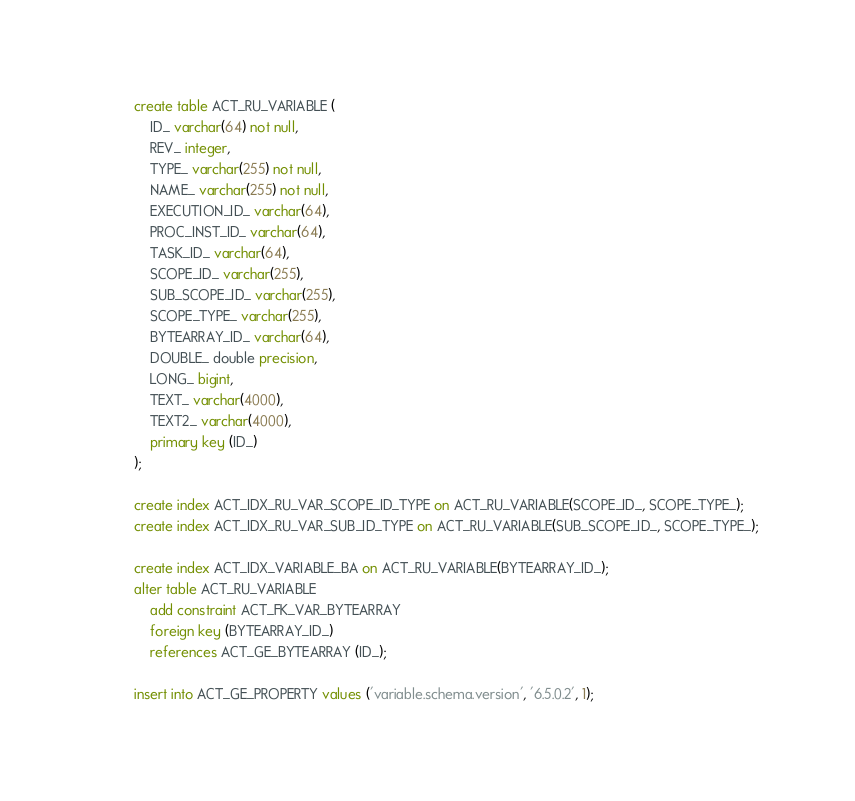Convert code to text. <code><loc_0><loc_0><loc_500><loc_500><_SQL_>create table ACT_RU_VARIABLE (
    ID_ varchar(64) not null,
    REV_ integer,
    TYPE_ varchar(255) not null,
    NAME_ varchar(255) not null,
    EXECUTION_ID_ varchar(64),
    PROC_INST_ID_ varchar(64),
    TASK_ID_ varchar(64),
    SCOPE_ID_ varchar(255),
    SUB_SCOPE_ID_ varchar(255),
    SCOPE_TYPE_ varchar(255),
    BYTEARRAY_ID_ varchar(64),
    DOUBLE_ double precision,
    LONG_ bigint,
    TEXT_ varchar(4000),
    TEXT2_ varchar(4000),
    primary key (ID_)
);

create index ACT_IDX_RU_VAR_SCOPE_ID_TYPE on ACT_RU_VARIABLE(SCOPE_ID_, SCOPE_TYPE_);
create index ACT_IDX_RU_VAR_SUB_ID_TYPE on ACT_RU_VARIABLE(SUB_SCOPE_ID_, SCOPE_TYPE_);

create index ACT_IDX_VARIABLE_BA on ACT_RU_VARIABLE(BYTEARRAY_ID_);
alter table ACT_RU_VARIABLE 
    add constraint ACT_FK_VAR_BYTEARRAY 
    foreign key (BYTEARRAY_ID_) 
    references ACT_GE_BYTEARRAY (ID_);

insert into ACT_GE_PROPERTY values ('variable.schema.version', '6.5.0.2', 1);</code> 